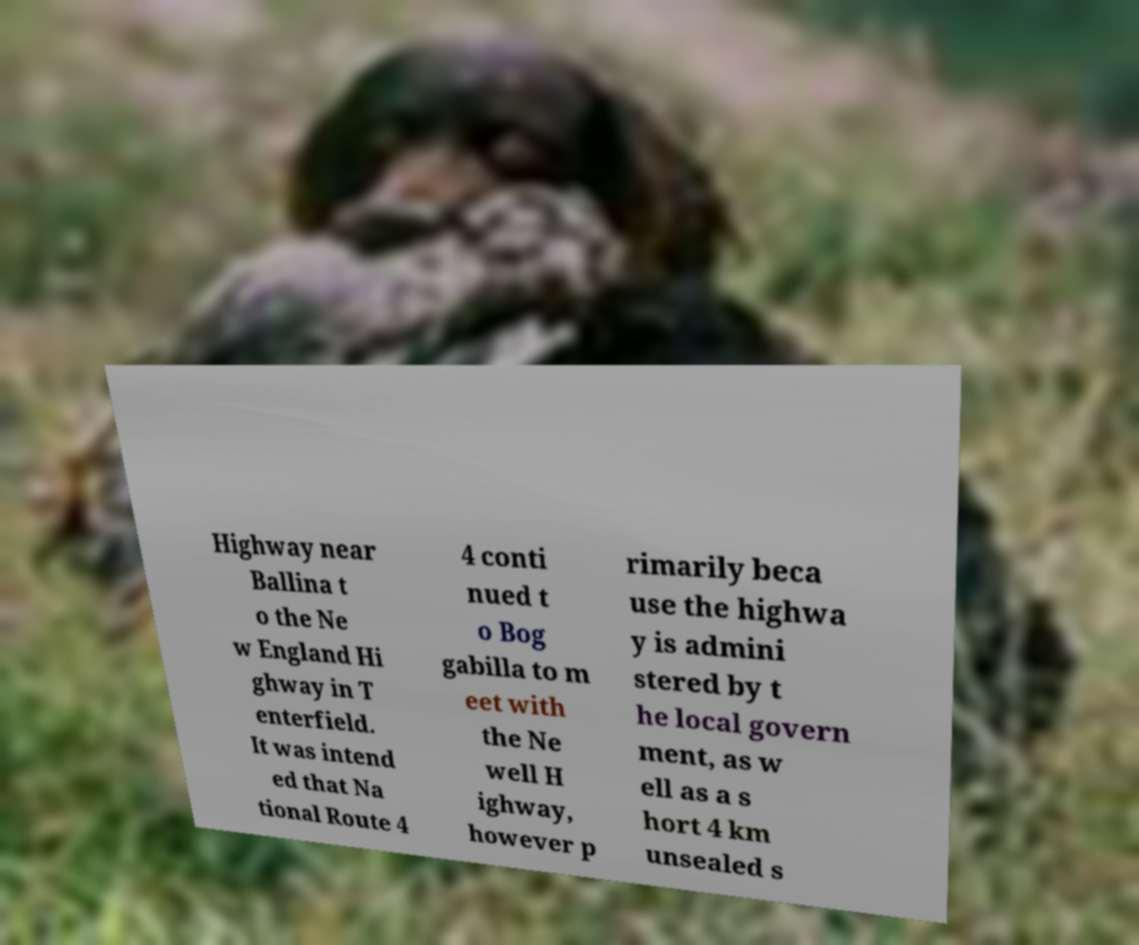Please identify and transcribe the text found in this image. Highway near Ballina t o the Ne w England Hi ghway in T enterfield. It was intend ed that Na tional Route 4 4 conti nued t o Bog gabilla to m eet with the Ne well H ighway, however p rimarily beca use the highwa y is admini stered by t he local govern ment, as w ell as a s hort 4 km unsealed s 